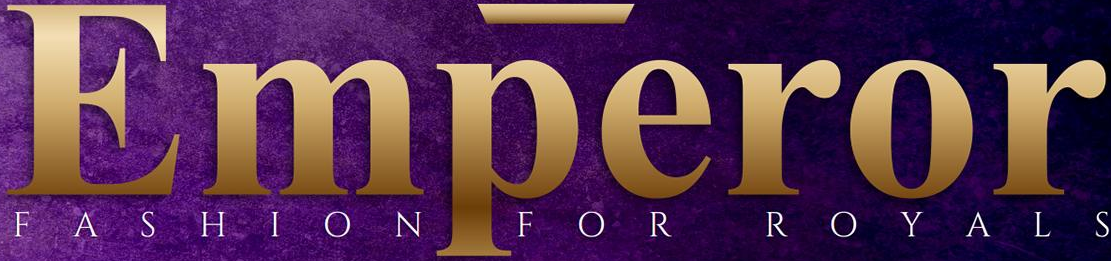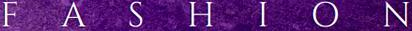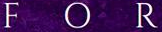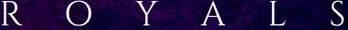Read the text content from these images in order, separated by a semicolon. Emperor; FASHION; FOR; ROYALS 